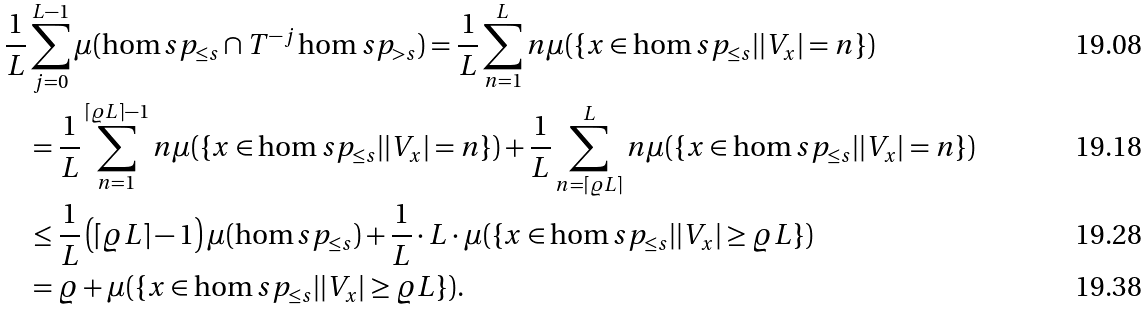Convert formula to latex. <formula><loc_0><loc_0><loc_500><loc_500>\frac { 1 } { L } & \sum _ { j = 0 } ^ { L - 1 } \mu ( \hom s p _ { \leq s } \cap T ^ { - j } \hom s p _ { > s } ) = \frac { 1 } { L } \sum _ { n = 1 } ^ { L } n \mu ( \{ x \in \hom s p _ { \leq s } | | V _ { x } | = n \} ) \\ & = \frac { 1 } { L } \sum _ { n = 1 } ^ { \lceil \varrho L \rceil - 1 } n \mu ( \{ x \in \hom s p _ { \leq s } | | V _ { x } | = n \} ) + \frac { 1 } { L } \sum _ { n = \lceil \varrho L \rceil } ^ { L } n \mu ( \{ x \in \hom s p _ { \leq s } | | V _ { x } | = n \} ) \\ & \leq \frac { 1 } { L } \left ( \lceil \varrho L \rceil - 1 \right ) \mu ( \hom s p _ { \leq s } ) + \frac { 1 } { L } \cdot L \cdot \mu ( \{ x \in \hom s p _ { \leq s } | | V _ { x } | \geq \varrho L \} ) \\ & = \varrho + \mu ( \{ x \in \hom s p _ { \leq s } | | V _ { x } | \geq \varrho L \} ) .</formula> 